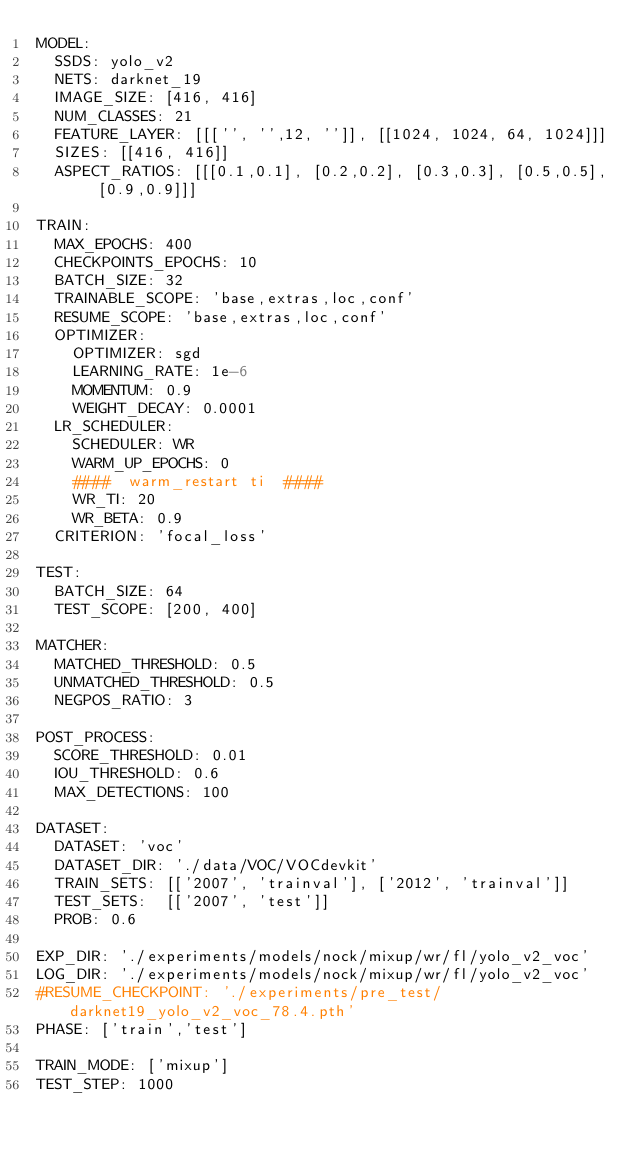Convert code to text. <code><loc_0><loc_0><loc_500><loc_500><_YAML_>MODEL:
  SSDS: yolo_v2
  NETS: darknet_19
  IMAGE_SIZE: [416, 416]
  NUM_CLASSES: 21
  FEATURE_LAYER: [[['', '',12, '']], [[1024, 1024, 64, 1024]]]
  SIZES: [[416, 416]]
  ASPECT_RATIOS: [[[0.1,0.1], [0.2,0.2], [0.3,0.3], [0.5,0.5], [0.9,0.9]]]

TRAIN:
  MAX_EPOCHS: 400
  CHECKPOINTS_EPOCHS: 10
  BATCH_SIZE: 32
  TRAINABLE_SCOPE: 'base,extras,loc,conf'
  RESUME_SCOPE: 'base,extras,loc,conf'
  OPTIMIZER:
    OPTIMIZER: sgd
    LEARNING_RATE: 1e-6
    MOMENTUM: 0.9
    WEIGHT_DECAY: 0.0001
  LR_SCHEDULER:
    SCHEDULER: WR
    WARM_UP_EPOCHS: 0
    ####  warm_restart ti  ####
    WR_TI: 20
    WR_BETA: 0.9
  CRITERION: 'focal_loss'

TEST:
  BATCH_SIZE: 64
  TEST_SCOPE: [200, 400]

MATCHER:
  MATCHED_THRESHOLD: 0.5
  UNMATCHED_THRESHOLD: 0.5
  NEGPOS_RATIO: 3

POST_PROCESS:
  SCORE_THRESHOLD: 0.01
  IOU_THRESHOLD: 0.6
  MAX_DETECTIONS: 100

DATASET:
  DATASET: 'voc'
  DATASET_DIR: './data/VOC/VOCdevkit'
  TRAIN_SETS: [['2007', 'trainval'], ['2012', 'trainval']]
  TEST_SETS:  [['2007', 'test']]
  PROB: 0.6

EXP_DIR: './experiments/models/nock/mixup/wr/fl/yolo_v2_voc'
LOG_DIR: './experiments/models/nock/mixup/wr/fl/yolo_v2_voc'
#RESUME_CHECKPOINT: './experiments/pre_test/darknet19_yolo_v2_voc_78.4.pth'
PHASE: ['train','test']

TRAIN_MODE: ['mixup']
TEST_STEP: 1000</code> 